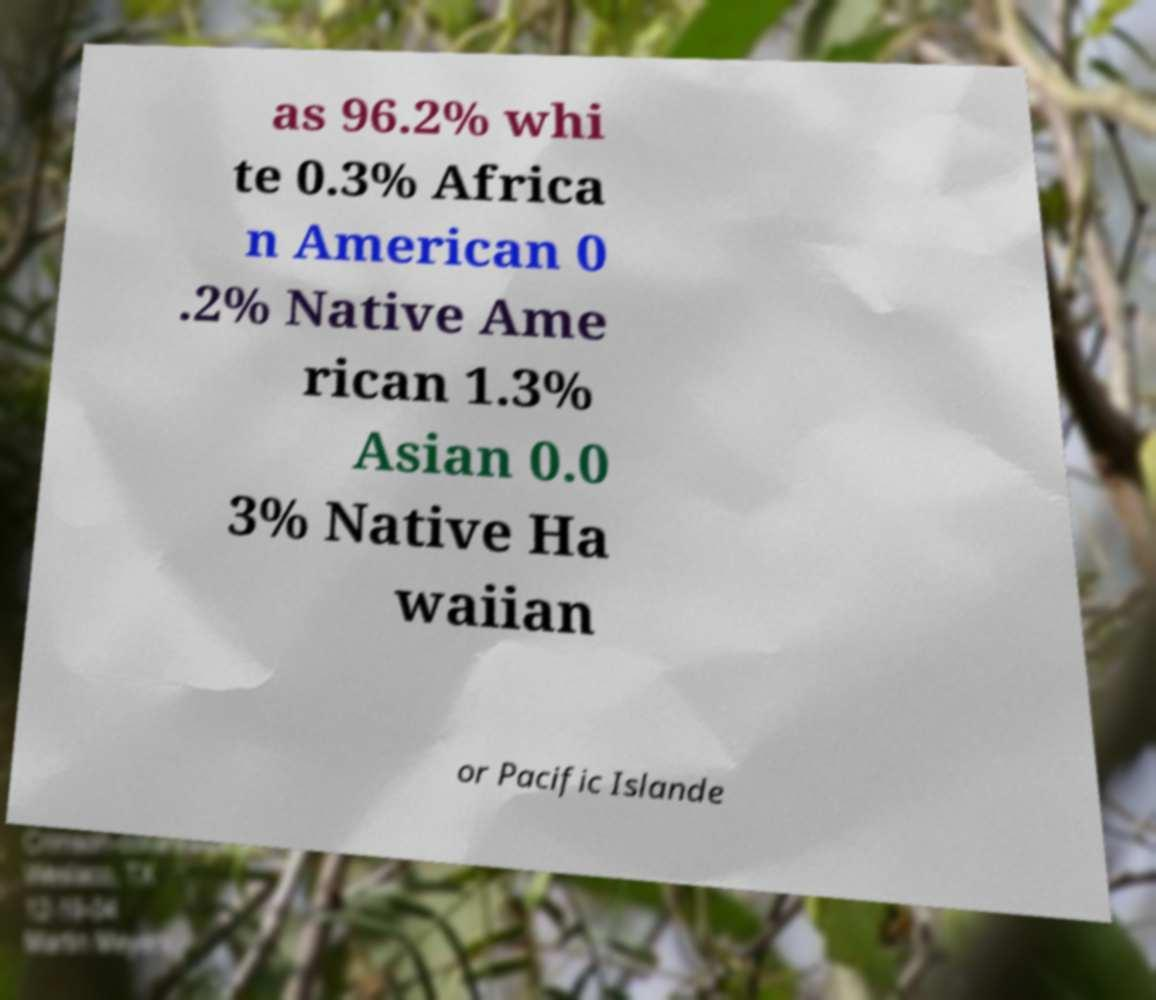Please read and relay the text visible in this image. What does it say? as 96.2% whi te 0.3% Africa n American 0 .2% Native Ame rican 1.3% Asian 0.0 3% Native Ha waiian or Pacific Islande 